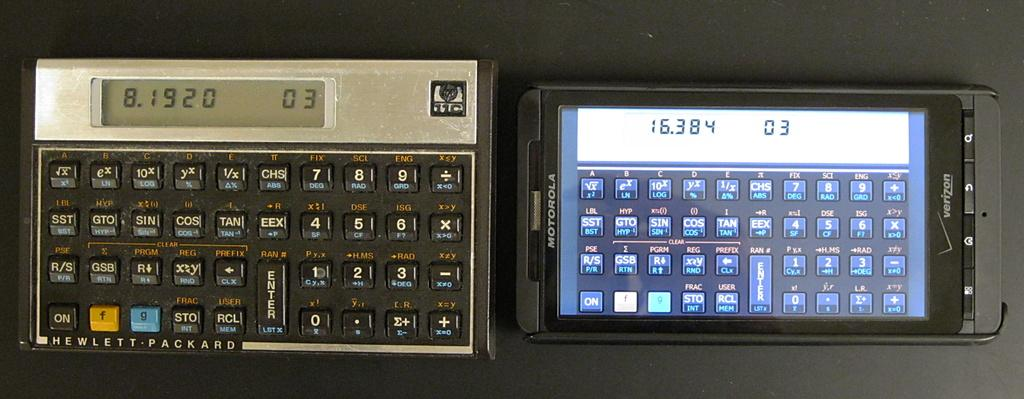Provide a one-sentence caption for the provided image. an old fashioned keyboard with the number 03 displayed. 